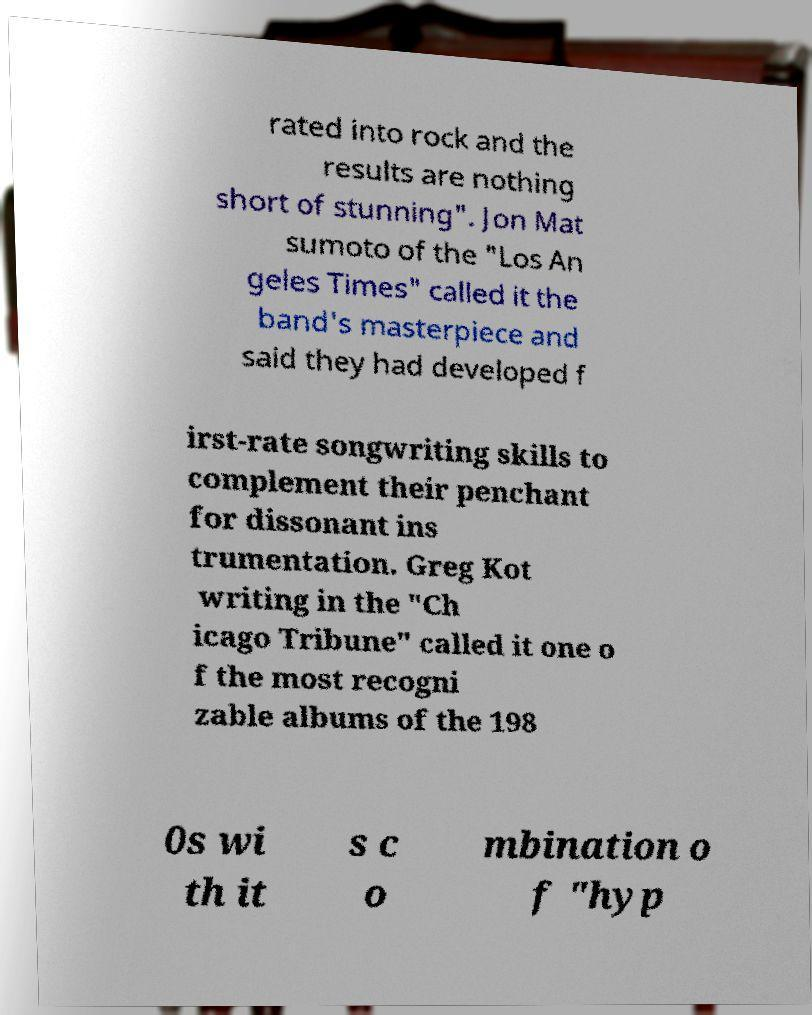Please identify and transcribe the text found in this image. rated into rock and the results are nothing short of stunning". Jon Mat sumoto of the "Los An geles Times" called it the band's masterpiece and said they had developed f irst-rate songwriting skills to complement their penchant for dissonant ins trumentation. Greg Kot writing in the "Ch icago Tribune" called it one o f the most recogni zable albums of the 198 0s wi th it s c o mbination o f "hyp 